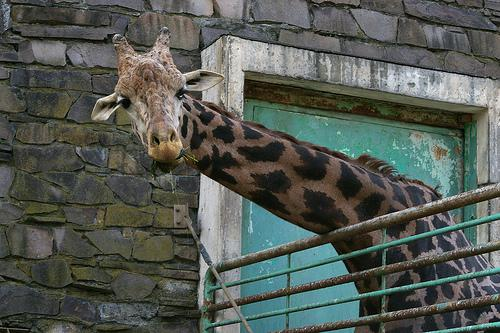Question: what is the giraffe doing?
Choices:
A. Sleeping.
B. Running.
C. Swimming.
D. Eating.
Answer with the letter. Answer: D Question: how many giraffes are in the picture?
Choices:
A. Two.
B. Three.
C. Four.
D. One.
Answer with the letter. Answer: D Question: when was the picture taken?
Choices:
A. Midnight.
B. Sunset.
C. Daytime.
D. Evening.
Answer with the letter. Answer: C Question: what is the building made of?
Choices:
A. Wood.
B. Glass.
C. Stone.
D. Metal.
Answer with the letter. Answer: C Question: what kind of animal is in the picture?
Choices:
A. Horse.
B. Donkey.
C. Elephant.
D. A giraffe.
Answer with the letter. Answer: D 